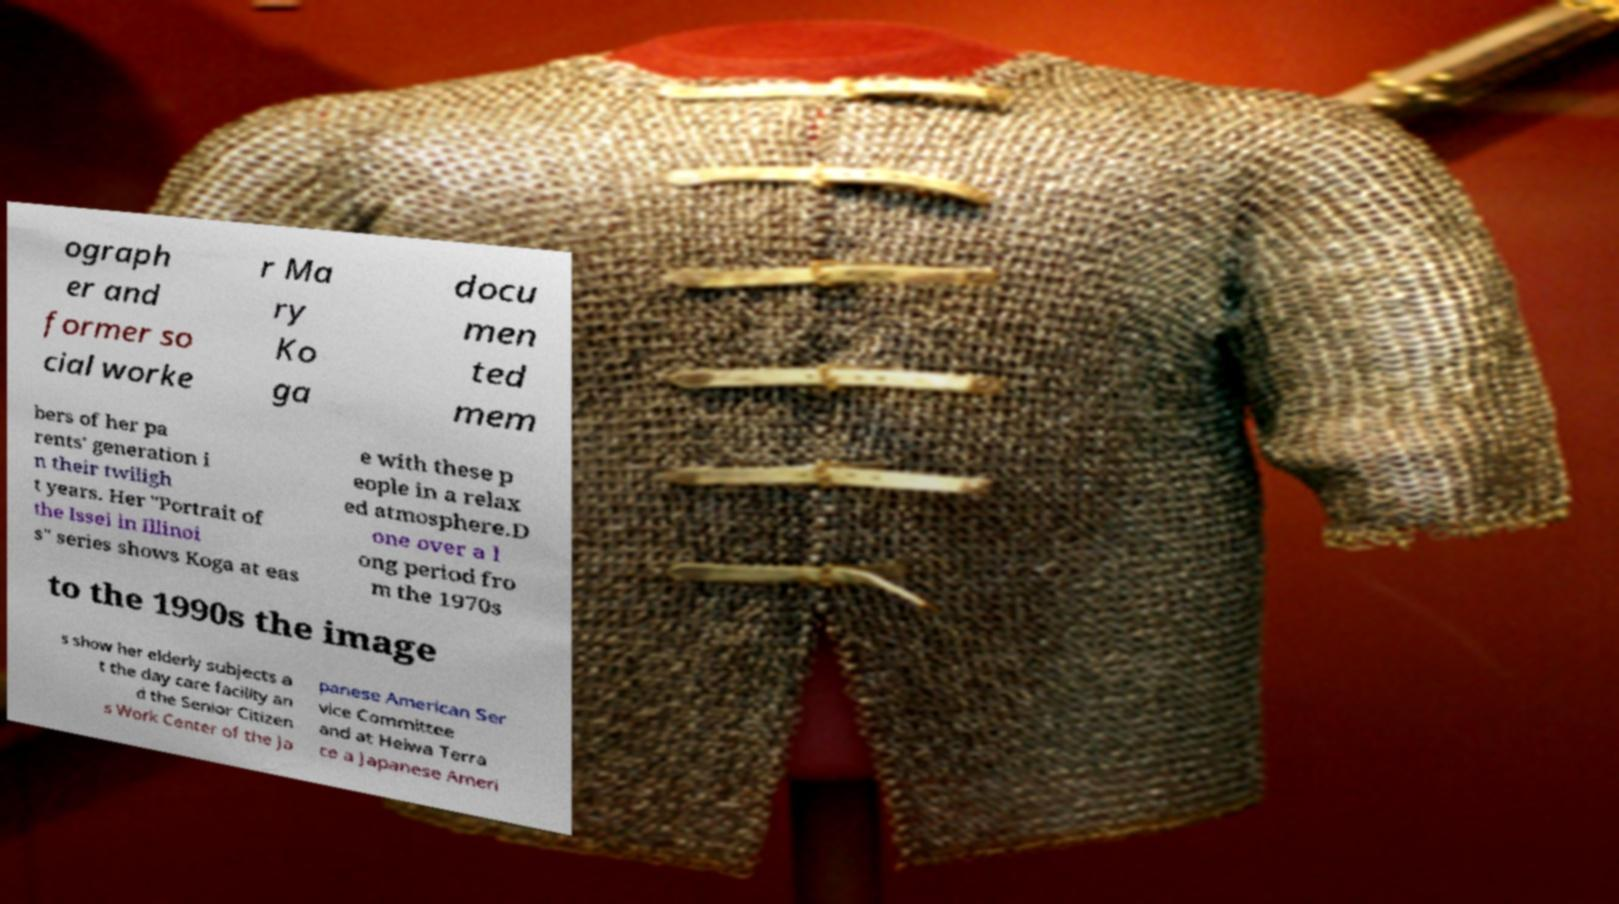Could you extract and type out the text from this image? ograph er and former so cial worke r Ma ry Ko ga docu men ted mem bers of her pa rents' generation i n their twiligh t years. Her "Portrait of the Issei in Illinoi s" series shows Koga at eas e with these p eople in a relax ed atmosphere.D one over a l ong period fro m the 1970s to the 1990s the image s show her elderly subjects a t the day care facility an d the Senior Citizen s Work Center of the Ja panese American Ser vice Committee and at Heiwa Terra ce a Japanese Ameri 